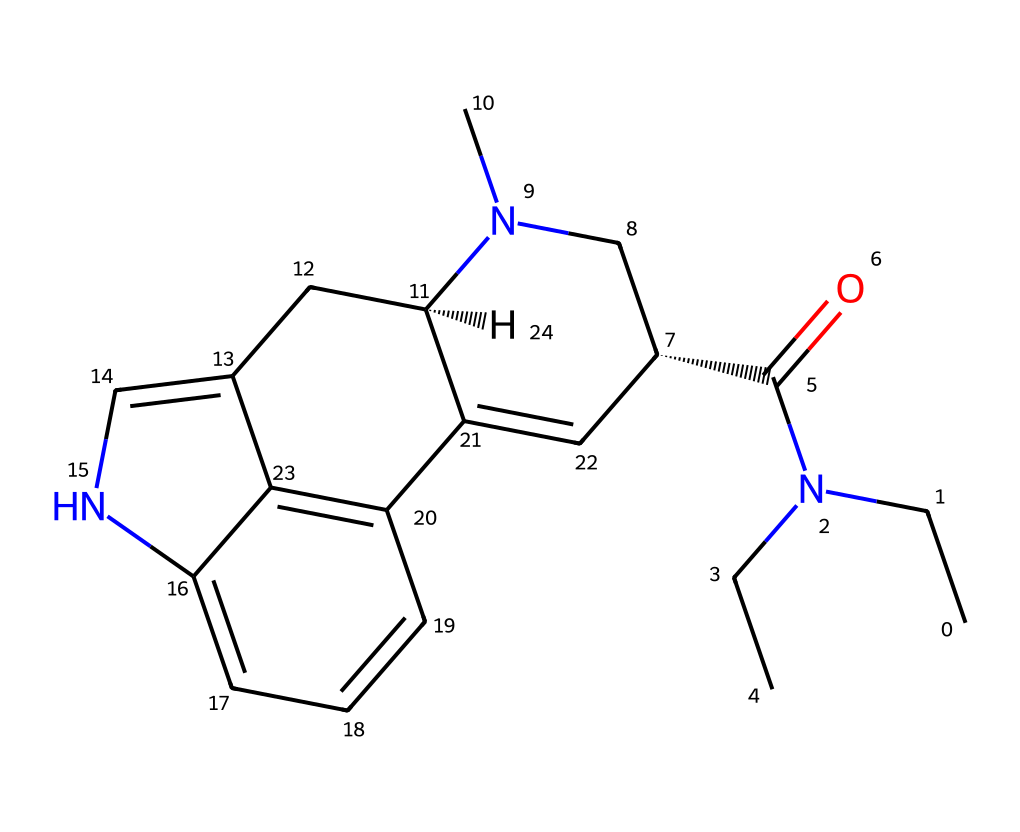What is the name of this chemical? The provided SMILES representation corresponds to lysergic acid diethylamide, commonly known as LSD. This can be confirmed by recognizing the structure and nomenclature associated with hallucinogenic compounds from the late 1960s.
Answer: LSD How many nitrogen atoms are present in the structure? By analyzing the SMILES representation, we can identify four nitrogen atoms (N). Each nitrogen atom contributes distinct properties to the chemical structure, influencing its classification and effects.
Answer: 4 What type of functional groups are present in LSD? The presence of the amide group (C(=O)N) and the tertiary amines (N(CC)) can be identified in the SMILES. These functional groups are essential in defining the chemical behavior and pharmacological activity of LSD.
Answer: amide, amine Does this chemical have any halogen atoms in its structure? By examining the SMILES notation, there are no halogen (F, Cl, Br, I) atoms indicated within the structure. The absence of halogens is significant as it suggests the chemical's behavior is not influenced by these elements.
Answer: no What is the stereochemistry of this compound? The presence of '@' symbols in the SMILES indicates chiral centers at those points. Specifically, there are two chiral centers in LSD affecting the stereochemistry, essential for its biological activity.
Answer: chiral What is the primary category of this compound? LSD primarily belongs to the category of hallucinogens, which are known for causing altered states of perception, cognition, and behavior. This classification is rooted in its structure and effects as derived from indole alkaloids.
Answer: hallucinogen 